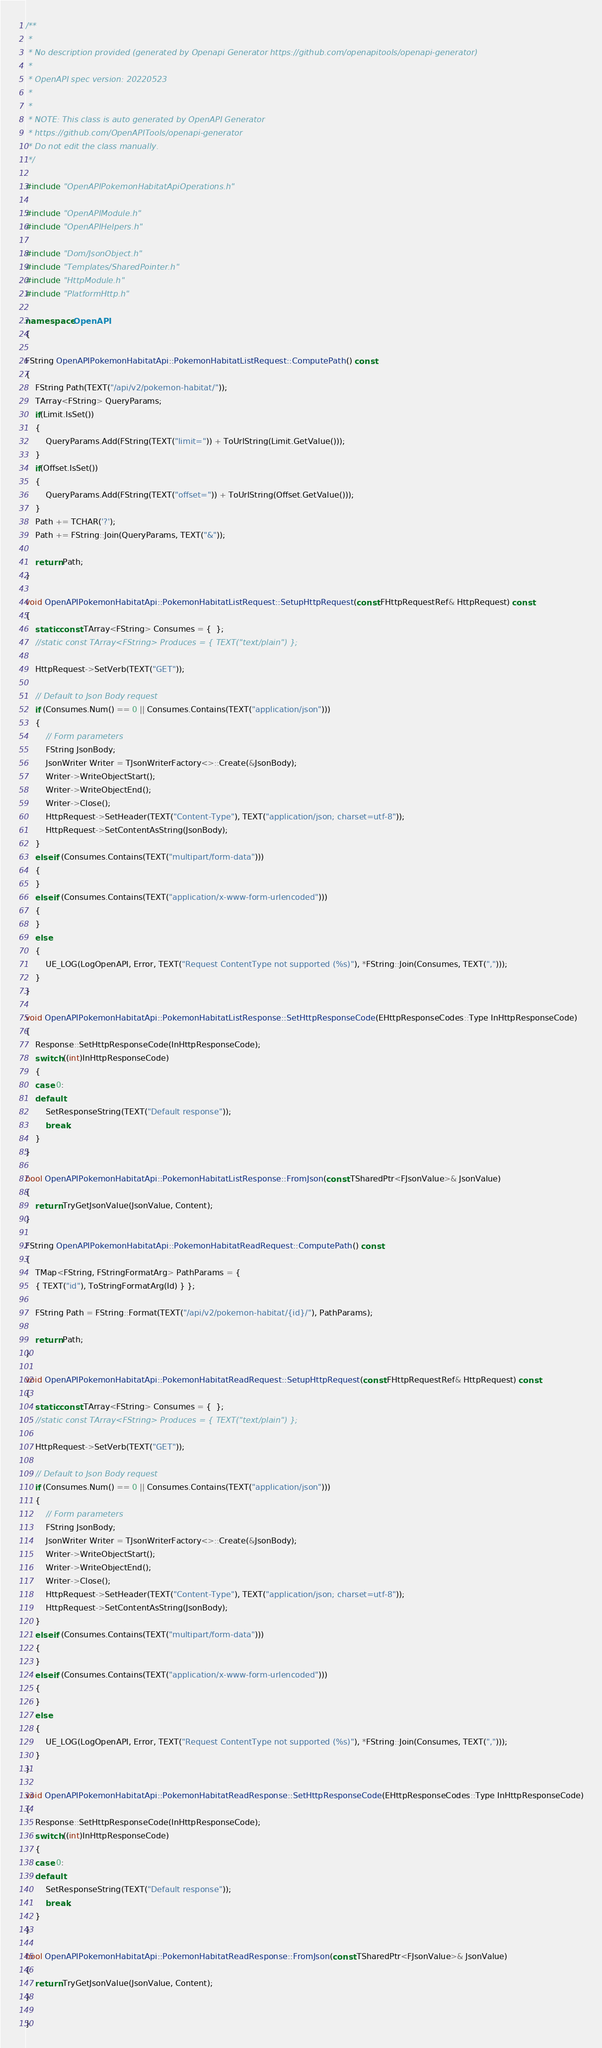<code> <loc_0><loc_0><loc_500><loc_500><_C++_>/**
 * 
 * No description provided (generated by Openapi Generator https://github.com/openapitools/openapi-generator)
 *
 * OpenAPI spec version: 20220523
 * 
 *
 * NOTE: This class is auto generated by OpenAPI Generator
 * https://github.com/OpenAPITools/openapi-generator
 * Do not edit the class manually.
 */

#include "OpenAPIPokemonHabitatApiOperations.h"

#include "OpenAPIModule.h"
#include "OpenAPIHelpers.h"

#include "Dom/JsonObject.h"
#include "Templates/SharedPointer.h"
#include "HttpModule.h"
#include "PlatformHttp.h"

namespace OpenAPI
{

FString OpenAPIPokemonHabitatApi::PokemonHabitatListRequest::ComputePath() const
{
	FString Path(TEXT("/api/v2/pokemon-habitat/"));
	TArray<FString> QueryParams;
	if(Limit.IsSet())
	{
		QueryParams.Add(FString(TEXT("limit=")) + ToUrlString(Limit.GetValue()));
	}
	if(Offset.IsSet())
	{
		QueryParams.Add(FString(TEXT("offset=")) + ToUrlString(Offset.GetValue()));
	}
	Path += TCHAR('?');
	Path += FString::Join(QueryParams, TEXT("&"));

	return Path;
}

void OpenAPIPokemonHabitatApi::PokemonHabitatListRequest::SetupHttpRequest(const FHttpRequestRef& HttpRequest) const
{
	static const TArray<FString> Consumes = {  };
	//static const TArray<FString> Produces = { TEXT("text/plain") };

	HttpRequest->SetVerb(TEXT("GET"));

	// Default to Json Body request
	if (Consumes.Num() == 0 || Consumes.Contains(TEXT("application/json")))
	{
		// Form parameters
		FString JsonBody;
		JsonWriter Writer = TJsonWriterFactory<>::Create(&JsonBody);
		Writer->WriteObjectStart();
		Writer->WriteObjectEnd();
		Writer->Close();
		HttpRequest->SetHeader(TEXT("Content-Type"), TEXT("application/json; charset=utf-8"));
		HttpRequest->SetContentAsString(JsonBody);
	}
	else if (Consumes.Contains(TEXT("multipart/form-data")))
	{
	}
	else if (Consumes.Contains(TEXT("application/x-www-form-urlencoded")))
	{
	}
	else
	{
		UE_LOG(LogOpenAPI, Error, TEXT("Request ContentType not supported (%s)"), *FString::Join(Consumes, TEXT(",")));
	}
}

void OpenAPIPokemonHabitatApi::PokemonHabitatListResponse::SetHttpResponseCode(EHttpResponseCodes::Type InHttpResponseCode)
{
	Response::SetHttpResponseCode(InHttpResponseCode);
	switch ((int)InHttpResponseCode)
	{
	case 0:
	default:
		SetResponseString(TEXT("Default response"));
		break;
	}
}

bool OpenAPIPokemonHabitatApi::PokemonHabitatListResponse::FromJson(const TSharedPtr<FJsonValue>& JsonValue)
{
	return TryGetJsonValue(JsonValue, Content);
}

FString OpenAPIPokemonHabitatApi::PokemonHabitatReadRequest::ComputePath() const
{
	TMap<FString, FStringFormatArg> PathParams = { 
	{ TEXT("id"), ToStringFormatArg(Id) } };

	FString Path = FString::Format(TEXT("/api/v2/pokemon-habitat/{id}/"), PathParams);

	return Path;
}

void OpenAPIPokemonHabitatApi::PokemonHabitatReadRequest::SetupHttpRequest(const FHttpRequestRef& HttpRequest) const
{
	static const TArray<FString> Consumes = {  };
	//static const TArray<FString> Produces = { TEXT("text/plain") };

	HttpRequest->SetVerb(TEXT("GET"));

	// Default to Json Body request
	if (Consumes.Num() == 0 || Consumes.Contains(TEXT("application/json")))
	{
		// Form parameters
		FString JsonBody;
		JsonWriter Writer = TJsonWriterFactory<>::Create(&JsonBody);
		Writer->WriteObjectStart();
		Writer->WriteObjectEnd();
		Writer->Close();
		HttpRequest->SetHeader(TEXT("Content-Type"), TEXT("application/json; charset=utf-8"));
		HttpRequest->SetContentAsString(JsonBody);
	}
	else if (Consumes.Contains(TEXT("multipart/form-data")))
	{
	}
	else if (Consumes.Contains(TEXT("application/x-www-form-urlencoded")))
	{
	}
	else
	{
		UE_LOG(LogOpenAPI, Error, TEXT("Request ContentType not supported (%s)"), *FString::Join(Consumes, TEXT(",")));
	}
}

void OpenAPIPokemonHabitatApi::PokemonHabitatReadResponse::SetHttpResponseCode(EHttpResponseCodes::Type InHttpResponseCode)
{
	Response::SetHttpResponseCode(InHttpResponseCode);
	switch ((int)InHttpResponseCode)
	{
	case 0:
	default:
		SetResponseString(TEXT("Default response"));
		break;
	}
}

bool OpenAPIPokemonHabitatApi::PokemonHabitatReadResponse::FromJson(const TSharedPtr<FJsonValue>& JsonValue)
{
	return TryGetJsonValue(JsonValue, Content);
}

}
</code> 